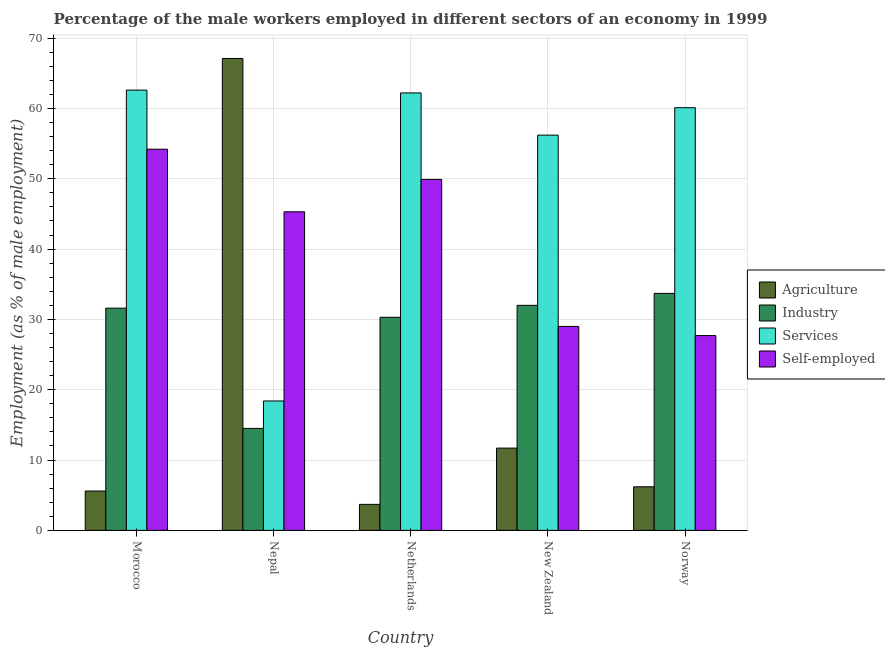How many different coloured bars are there?
Your answer should be very brief. 4. How many bars are there on the 1st tick from the left?
Your response must be concise. 4. In how many cases, is the number of bars for a given country not equal to the number of legend labels?
Offer a very short reply. 0. What is the percentage of male workers in services in Nepal?
Provide a short and direct response. 18.4. Across all countries, what is the maximum percentage of self employed male workers?
Keep it short and to the point. 54.2. Across all countries, what is the minimum percentage of male workers in agriculture?
Keep it short and to the point. 3.7. In which country was the percentage of male workers in industry maximum?
Provide a succinct answer. Norway. What is the total percentage of male workers in industry in the graph?
Make the answer very short. 142.1. What is the difference between the percentage of male workers in industry in Nepal and that in Norway?
Keep it short and to the point. -19.2. What is the difference between the percentage of male workers in industry in New Zealand and the percentage of male workers in agriculture in Netherlands?
Offer a very short reply. 28.3. What is the average percentage of male workers in services per country?
Offer a very short reply. 51.9. What is the difference between the percentage of self employed male workers and percentage of male workers in services in New Zealand?
Your answer should be very brief. -27.2. What is the ratio of the percentage of male workers in agriculture in Morocco to that in New Zealand?
Keep it short and to the point. 0.48. Is the percentage of male workers in services in Nepal less than that in Norway?
Provide a succinct answer. Yes. Is the difference between the percentage of male workers in agriculture in Netherlands and Norway greater than the difference between the percentage of male workers in services in Netherlands and Norway?
Your response must be concise. No. What is the difference between the highest and the second highest percentage of male workers in services?
Ensure brevity in your answer.  0.4. What is the difference between the highest and the lowest percentage of male workers in industry?
Your response must be concise. 19.2. Is it the case that in every country, the sum of the percentage of male workers in agriculture and percentage of self employed male workers is greater than the sum of percentage of male workers in industry and percentage of male workers in services?
Give a very brief answer. No. What does the 4th bar from the left in New Zealand represents?
Ensure brevity in your answer.  Self-employed. What does the 4th bar from the right in Netherlands represents?
Keep it short and to the point. Agriculture. Is it the case that in every country, the sum of the percentage of male workers in agriculture and percentage of male workers in industry is greater than the percentage of male workers in services?
Provide a succinct answer. No. Are the values on the major ticks of Y-axis written in scientific E-notation?
Keep it short and to the point. No. Does the graph contain any zero values?
Ensure brevity in your answer.  No. Does the graph contain grids?
Give a very brief answer. Yes. Where does the legend appear in the graph?
Offer a very short reply. Center right. How many legend labels are there?
Offer a terse response. 4. What is the title of the graph?
Keep it short and to the point. Percentage of the male workers employed in different sectors of an economy in 1999. What is the label or title of the Y-axis?
Give a very brief answer. Employment (as % of male employment). What is the Employment (as % of male employment) of Agriculture in Morocco?
Ensure brevity in your answer.  5.6. What is the Employment (as % of male employment) in Industry in Morocco?
Your answer should be very brief. 31.6. What is the Employment (as % of male employment) in Services in Morocco?
Make the answer very short. 62.6. What is the Employment (as % of male employment) in Self-employed in Morocco?
Provide a succinct answer. 54.2. What is the Employment (as % of male employment) in Agriculture in Nepal?
Offer a very short reply. 67.1. What is the Employment (as % of male employment) in Services in Nepal?
Keep it short and to the point. 18.4. What is the Employment (as % of male employment) of Self-employed in Nepal?
Offer a very short reply. 45.3. What is the Employment (as % of male employment) in Agriculture in Netherlands?
Keep it short and to the point. 3.7. What is the Employment (as % of male employment) of Industry in Netherlands?
Keep it short and to the point. 30.3. What is the Employment (as % of male employment) of Services in Netherlands?
Keep it short and to the point. 62.2. What is the Employment (as % of male employment) of Self-employed in Netherlands?
Offer a very short reply. 49.9. What is the Employment (as % of male employment) of Agriculture in New Zealand?
Offer a terse response. 11.7. What is the Employment (as % of male employment) of Services in New Zealand?
Your answer should be very brief. 56.2. What is the Employment (as % of male employment) of Self-employed in New Zealand?
Ensure brevity in your answer.  29. What is the Employment (as % of male employment) in Agriculture in Norway?
Keep it short and to the point. 6.2. What is the Employment (as % of male employment) of Industry in Norway?
Offer a terse response. 33.7. What is the Employment (as % of male employment) of Services in Norway?
Your response must be concise. 60.1. What is the Employment (as % of male employment) of Self-employed in Norway?
Your answer should be very brief. 27.7. Across all countries, what is the maximum Employment (as % of male employment) of Agriculture?
Provide a succinct answer. 67.1. Across all countries, what is the maximum Employment (as % of male employment) in Industry?
Provide a succinct answer. 33.7. Across all countries, what is the maximum Employment (as % of male employment) in Services?
Make the answer very short. 62.6. Across all countries, what is the maximum Employment (as % of male employment) in Self-employed?
Offer a terse response. 54.2. Across all countries, what is the minimum Employment (as % of male employment) of Agriculture?
Your response must be concise. 3.7. Across all countries, what is the minimum Employment (as % of male employment) in Industry?
Provide a short and direct response. 14.5. Across all countries, what is the minimum Employment (as % of male employment) of Services?
Give a very brief answer. 18.4. Across all countries, what is the minimum Employment (as % of male employment) of Self-employed?
Ensure brevity in your answer.  27.7. What is the total Employment (as % of male employment) in Agriculture in the graph?
Give a very brief answer. 94.3. What is the total Employment (as % of male employment) in Industry in the graph?
Your response must be concise. 142.1. What is the total Employment (as % of male employment) in Services in the graph?
Provide a short and direct response. 259.5. What is the total Employment (as % of male employment) in Self-employed in the graph?
Your answer should be compact. 206.1. What is the difference between the Employment (as % of male employment) of Agriculture in Morocco and that in Nepal?
Keep it short and to the point. -61.5. What is the difference between the Employment (as % of male employment) in Industry in Morocco and that in Nepal?
Provide a short and direct response. 17.1. What is the difference between the Employment (as % of male employment) in Services in Morocco and that in Nepal?
Your response must be concise. 44.2. What is the difference between the Employment (as % of male employment) in Agriculture in Morocco and that in Netherlands?
Offer a terse response. 1.9. What is the difference between the Employment (as % of male employment) in Industry in Morocco and that in Netherlands?
Your answer should be very brief. 1.3. What is the difference between the Employment (as % of male employment) of Services in Morocco and that in Netherlands?
Keep it short and to the point. 0.4. What is the difference between the Employment (as % of male employment) of Agriculture in Morocco and that in New Zealand?
Your answer should be compact. -6.1. What is the difference between the Employment (as % of male employment) of Industry in Morocco and that in New Zealand?
Your answer should be very brief. -0.4. What is the difference between the Employment (as % of male employment) of Services in Morocco and that in New Zealand?
Provide a succinct answer. 6.4. What is the difference between the Employment (as % of male employment) in Self-employed in Morocco and that in New Zealand?
Keep it short and to the point. 25.2. What is the difference between the Employment (as % of male employment) of Agriculture in Morocco and that in Norway?
Ensure brevity in your answer.  -0.6. What is the difference between the Employment (as % of male employment) of Industry in Morocco and that in Norway?
Your answer should be very brief. -2.1. What is the difference between the Employment (as % of male employment) of Services in Morocco and that in Norway?
Provide a succinct answer. 2.5. What is the difference between the Employment (as % of male employment) in Agriculture in Nepal and that in Netherlands?
Provide a succinct answer. 63.4. What is the difference between the Employment (as % of male employment) in Industry in Nepal and that in Netherlands?
Provide a short and direct response. -15.8. What is the difference between the Employment (as % of male employment) in Services in Nepal and that in Netherlands?
Your answer should be very brief. -43.8. What is the difference between the Employment (as % of male employment) of Self-employed in Nepal and that in Netherlands?
Your answer should be very brief. -4.6. What is the difference between the Employment (as % of male employment) of Agriculture in Nepal and that in New Zealand?
Offer a terse response. 55.4. What is the difference between the Employment (as % of male employment) in Industry in Nepal and that in New Zealand?
Give a very brief answer. -17.5. What is the difference between the Employment (as % of male employment) in Services in Nepal and that in New Zealand?
Your response must be concise. -37.8. What is the difference between the Employment (as % of male employment) of Agriculture in Nepal and that in Norway?
Give a very brief answer. 60.9. What is the difference between the Employment (as % of male employment) in Industry in Nepal and that in Norway?
Your answer should be very brief. -19.2. What is the difference between the Employment (as % of male employment) in Services in Nepal and that in Norway?
Offer a terse response. -41.7. What is the difference between the Employment (as % of male employment) in Self-employed in Nepal and that in Norway?
Your answer should be very brief. 17.6. What is the difference between the Employment (as % of male employment) of Agriculture in Netherlands and that in New Zealand?
Provide a short and direct response. -8. What is the difference between the Employment (as % of male employment) in Industry in Netherlands and that in New Zealand?
Make the answer very short. -1.7. What is the difference between the Employment (as % of male employment) in Self-employed in Netherlands and that in New Zealand?
Your answer should be compact. 20.9. What is the difference between the Employment (as % of male employment) of Services in Netherlands and that in Norway?
Offer a terse response. 2.1. What is the difference between the Employment (as % of male employment) in Self-employed in Netherlands and that in Norway?
Provide a succinct answer. 22.2. What is the difference between the Employment (as % of male employment) of Industry in New Zealand and that in Norway?
Offer a very short reply. -1.7. What is the difference between the Employment (as % of male employment) of Services in New Zealand and that in Norway?
Your answer should be compact. -3.9. What is the difference between the Employment (as % of male employment) of Self-employed in New Zealand and that in Norway?
Make the answer very short. 1.3. What is the difference between the Employment (as % of male employment) in Agriculture in Morocco and the Employment (as % of male employment) in Industry in Nepal?
Your response must be concise. -8.9. What is the difference between the Employment (as % of male employment) in Agriculture in Morocco and the Employment (as % of male employment) in Self-employed in Nepal?
Your response must be concise. -39.7. What is the difference between the Employment (as % of male employment) in Industry in Morocco and the Employment (as % of male employment) in Self-employed in Nepal?
Provide a succinct answer. -13.7. What is the difference between the Employment (as % of male employment) of Services in Morocco and the Employment (as % of male employment) of Self-employed in Nepal?
Offer a very short reply. 17.3. What is the difference between the Employment (as % of male employment) in Agriculture in Morocco and the Employment (as % of male employment) in Industry in Netherlands?
Your answer should be very brief. -24.7. What is the difference between the Employment (as % of male employment) in Agriculture in Morocco and the Employment (as % of male employment) in Services in Netherlands?
Offer a very short reply. -56.6. What is the difference between the Employment (as % of male employment) of Agriculture in Morocco and the Employment (as % of male employment) of Self-employed in Netherlands?
Provide a succinct answer. -44.3. What is the difference between the Employment (as % of male employment) of Industry in Morocco and the Employment (as % of male employment) of Services in Netherlands?
Give a very brief answer. -30.6. What is the difference between the Employment (as % of male employment) of Industry in Morocco and the Employment (as % of male employment) of Self-employed in Netherlands?
Your answer should be very brief. -18.3. What is the difference between the Employment (as % of male employment) of Services in Morocco and the Employment (as % of male employment) of Self-employed in Netherlands?
Provide a short and direct response. 12.7. What is the difference between the Employment (as % of male employment) of Agriculture in Morocco and the Employment (as % of male employment) of Industry in New Zealand?
Offer a very short reply. -26.4. What is the difference between the Employment (as % of male employment) in Agriculture in Morocco and the Employment (as % of male employment) in Services in New Zealand?
Offer a terse response. -50.6. What is the difference between the Employment (as % of male employment) of Agriculture in Morocco and the Employment (as % of male employment) of Self-employed in New Zealand?
Your answer should be compact. -23.4. What is the difference between the Employment (as % of male employment) in Industry in Morocco and the Employment (as % of male employment) in Services in New Zealand?
Offer a terse response. -24.6. What is the difference between the Employment (as % of male employment) of Services in Morocco and the Employment (as % of male employment) of Self-employed in New Zealand?
Your answer should be compact. 33.6. What is the difference between the Employment (as % of male employment) of Agriculture in Morocco and the Employment (as % of male employment) of Industry in Norway?
Provide a short and direct response. -28.1. What is the difference between the Employment (as % of male employment) of Agriculture in Morocco and the Employment (as % of male employment) of Services in Norway?
Keep it short and to the point. -54.5. What is the difference between the Employment (as % of male employment) of Agriculture in Morocco and the Employment (as % of male employment) of Self-employed in Norway?
Your answer should be compact. -22.1. What is the difference between the Employment (as % of male employment) of Industry in Morocco and the Employment (as % of male employment) of Services in Norway?
Your answer should be very brief. -28.5. What is the difference between the Employment (as % of male employment) in Industry in Morocco and the Employment (as % of male employment) in Self-employed in Norway?
Provide a short and direct response. 3.9. What is the difference between the Employment (as % of male employment) of Services in Morocco and the Employment (as % of male employment) of Self-employed in Norway?
Provide a short and direct response. 34.9. What is the difference between the Employment (as % of male employment) of Agriculture in Nepal and the Employment (as % of male employment) of Industry in Netherlands?
Give a very brief answer. 36.8. What is the difference between the Employment (as % of male employment) in Agriculture in Nepal and the Employment (as % of male employment) in Self-employed in Netherlands?
Your answer should be compact. 17.2. What is the difference between the Employment (as % of male employment) in Industry in Nepal and the Employment (as % of male employment) in Services in Netherlands?
Provide a short and direct response. -47.7. What is the difference between the Employment (as % of male employment) of Industry in Nepal and the Employment (as % of male employment) of Self-employed in Netherlands?
Provide a succinct answer. -35.4. What is the difference between the Employment (as % of male employment) in Services in Nepal and the Employment (as % of male employment) in Self-employed in Netherlands?
Offer a terse response. -31.5. What is the difference between the Employment (as % of male employment) in Agriculture in Nepal and the Employment (as % of male employment) in Industry in New Zealand?
Offer a terse response. 35.1. What is the difference between the Employment (as % of male employment) of Agriculture in Nepal and the Employment (as % of male employment) of Self-employed in New Zealand?
Offer a very short reply. 38.1. What is the difference between the Employment (as % of male employment) in Industry in Nepal and the Employment (as % of male employment) in Services in New Zealand?
Provide a short and direct response. -41.7. What is the difference between the Employment (as % of male employment) in Industry in Nepal and the Employment (as % of male employment) in Self-employed in New Zealand?
Give a very brief answer. -14.5. What is the difference between the Employment (as % of male employment) of Services in Nepal and the Employment (as % of male employment) of Self-employed in New Zealand?
Give a very brief answer. -10.6. What is the difference between the Employment (as % of male employment) in Agriculture in Nepal and the Employment (as % of male employment) in Industry in Norway?
Keep it short and to the point. 33.4. What is the difference between the Employment (as % of male employment) in Agriculture in Nepal and the Employment (as % of male employment) in Services in Norway?
Your answer should be compact. 7. What is the difference between the Employment (as % of male employment) of Agriculture in Nepal and the Employment (as % of male employment) of Self-employed in Norway?
Your answer should be very brief. 39.4. What is the difference between the Employment (as % of male employment) of Industry in Nepal and the Employment (as % of male employment) of Services in Norway?
Provide a succinct answer. -45.6. What is the difference between the Employment (as % of male employment) in Industry in Nepal and the Employment (as % of male employment) in Self-employed in Norway?
Make the answer very short. -13.2. What is the difference between the Employment (as % of male employment) of Services in Nepal and the Employment (as % of male employment) of Self-employed in Norway?
Offer a terse response. -9.3. What is the difference between the Employment (as % of male employment) of Agriculture in Netherlands and the Employment (as % of male employment) of Industry in New Zealand?
Give a very brief answer. -28.3. What is the difference between the Employment (as % of male employment) of Agriculture in Netherlands and the Employment (as % of male employment) of Services in New Zealand?
Make the answer very short. -52.5. What is the difference between the Employment (as % of male employment) of Agriculture in Netherlands and the Employment (as % of male employment) of Self-employed in New Zealand?
Your answer should be very brief. -25.3. What is the difference between the Employment (as % of male employment) of Industry in Netherlands and the Employment (as % of male employment) of Services in New Zealand?
Offer a terse response. -25.9. What is the difference between the Employment (as % of male employment) in Services in Netherlands and the Employment (as % of male employment) in Self-employed in New Zealand?
Make the answer very short. 33.2. What is the difference between the Employment (as % of male employment) in Agriculture in Netherlands and the Employment (as % of male employment) in Services in Norway?
Your answer should be compact. -56.4. What is the difference between the Employment (as % of male employment) of Industry in Netherlands and the Employment (as % of male employment) of Services in Norway?
Ensure brevity in your answer.  -29.8. What is the difference between the Employment (as % of male employment) of Services in Netherlands and the Employment (as % of male employment) of Self-employed in Norway?
Your response must be concise. 34.5. What is the difference between the Employment (as % of male employment) in Agriculture in New Zealand and the Employment (as % of male employment) in Industry in Norway?
Offer a terse response. -22. What is the difference between the Employment (as % of male employment) in Agriculture in New Zealand and the Employment (as % of male employment) in Services in Norway?
Offer a terse response. -48.4. What is the difference between the Employment (as % of male employment) of Industry in New Zealand and the Employment (as % of male employment) of Services in Norway?
Provide a short and direct response. -28.1. What is the difference between the Employment (as % of male employment) in Industry in New Zealand and the Employment (as % of male employment) in Self-employed in Norway?
Your answer should be compact. 4.3. What is the average Employment (as % of male employment) of Agriculture per country?
Your response must be concise. 18.86. What is the average Employment (as % of male employment) of Industry per country?
Make the answer very short. 28.42. What is the average Employment (as % of male employment) of Services per country?
Provide a succinct answer. 51.9. What is the average Employment (as % of male employment) of Self-employed per country?
Offer a terse response. 41.22. What is the difference between the Employment (as % of male employment) of Agriculture and Employment (as % of male employment) of Services in Morocco?
Offer a terse response. -57. What is the difference between the Employment (as % of male employment) in Agriculture and Employment (as % of male employment) in Self-employed in Morocco?
Provide a succinct answer. -48.6. What is the difference between the Employment (as % of male employment) in Industry and Employment (as % of male employment) in Services in Morocco?
Make the answer very short. -31. What is the difference between the Employment (as % of male employment) in Industry and Employment (as % of male employment) in Self-employed in Morocco?
Offer a very short reply. -22.6. What is the difference between the Employment (as % of male employment) in Services and Employment (as % of male employment) in Self-employed in Morocco?
Ensure brevity in your answer.  8.4. What is the difference between the Employment (as % of male employment) of Agriculture and Employment (as % of male employment) of Industry in Nepal?
Your answer should be very brief. 52.6. What is the difference between the Employment (as % of male employment) in Agriculture and Employment (as % of male employment) in Services in Nepal?
Provide a succinct answer. 48.7. What is the difference between the Employment (as % of male employment) in Agriculture and Employment (as % of male employment) in Self-employed in Nepal?
Offer a terse response. 21.8. What is the difference between the Employment (as % of male employment) of Industry and Employment (as % of male employment) of Services in Nepal?
Your answer should be compact. -3.9. What is the difference between the Employment (as % of male employment) in Industry and Employment (as % of male employment) in Self-employed in Nepal?
Your response must be concise. -30.8. What is the difference between the Employment (as % of male employment) in Services and Employment (as % of male employment) in Self-employed in Nepal?
Provide a short and direct response. -26.9. What is the difference between the Employment (as % of male employment) in Agriculture and Employment (as % of male employment) in Industry in Netherlands?
Ensure brevity in your answer.  -26.6. What is the difference between the Employment (as % of male employment) of Agriculture and Employment (as % of male employment) of Services in Netherlands?
Offer a very short reply. -58.5. What is the difference between the Employment (as % of male employment) of Agriculture and Employment (as % of male employment) of Self-employed in Netherlands?
Keep it short and to the point. -46.2. What is the difference between the Employment (as % of male employment) in Industry and Employment (as % of male employment) in Services in Netherlands?
Provide a succinct answer. -31.9. What is the difference between the Employment (as % of male employment) of Industry and Employment (as % of male employment) of Self-employed in Netherlands?
Your response must be concise. -19.6. What is the difference between the Employment (as % of male employment) in Agriculture and Employment (as % of male employment) in Industry in New Zealand?
Offer a terse response. -20.3. What is the difference between the Employment (as % of male employment) of Agriculture and Employment (as % of male employment) of Services in New Zealand?
Offer a very short reply. -44.5. What is the difference between the Employment (as % of male employment) in Agriculture and Employment (as % of male employment) in Self-employed in New Zealand?
Ensure brevity in your answer.  -17.3. What is the difference between the Employment (as % of male employment) in Industry and Employment (as % of male employment) in Services in New Zealand?
Your response must be concise. -24.2. What is the difference between the Employment (as % of male employment) of Services and Employment (as % of male employment) of Self-employed in New Zealand?
Offer a very short reply. 27.2. What is the difference between the Employment (as % of male employment) of Agriculture and Employment (as % of male employment) of Industry in Norway?
Ensure brevity in your answer.  -27.5. What is the difference between the Employment (as % of male employment) of Agriculture and Employment (as % of male employment) of Services in Norway?
Offer a terse response. -53.9. What is the difference between the Employment (as % of male employment) in Agriculture and Employment (as % of male employment) in Self-employed in Norway?
Provide a short and direct response. -21.5. What is the difference between the Employment (as % of male employment) in Industry and Employment (as % of male employment) in Services in Norway?
Make the answer very short. -26.4. What is the difference between the Employment (as % of male employment) in Services and Employment (as % of male employment) in Self-employed in Norway?
Give a very brief answer. 32.4. What is the ratio of the Employment (as % of male employment) of Agriculture in Morocco to that in Nepal?
Provide a short and direct response. 0.08. What is the ratio of the Employment (as % of male employment) of Industry in Morocco to that in Nepal?
Offer a terse response. 2.18. What is the ratio of the Employment (as % of male employment) in Services in Morocco to that in Nepal?
Offer a very short reply. 3.4. What is the ratio of the Employment (as % of male employment) in Self-employed in Morocco to that in Nepal?
Your answer should be very brief. 1.2. What is the ratio of the Employment (as % of male employment) of Agriculture in Morocco to that in Netherlands?
Keep it short and to the point. 1.51. What is the ratio of the Employment (as % of male employment) of Industry in Morocco to that in Netherlands?
Offer a very short reply. 1.04. What is the ratio of the Employment (as % of male employment) in Services in Morocco to that in Netherlands?
Your response must be concise. 1.01. What is the ratio of the Employment (as % of male employment) of Self-employed in Morocco to that in Netherlands?
Ensure brevity in your answer.  1.09. What is the ratio of the Employment (as % of male employment) in Agriculture in Morocco to that in New Zealand?
Your answer should be very brief. 0.48. What is the ratio of the Employment (as % of male employment) of Industry in Morocco to that in New Zealand?
Make the answer very short. 0.99. What is the ratio of the Employment (as % of male employment) of Services in Morocco to that in New Zealand?
Your response must be concise. 1.11. What is the ratio of the Employment (as % of male employment) in Self-employed in Morocco to that in New Zealand?
Your answer should be very brief. 1.87. What is the ratio of the Employment (as % of male employment) in Agriculture in Morocco to that in Norway?
Your response must be concise. 0.9. What is the ratio of the Employment (as % of male employment) in Industry in Morocco to that in Norway?
Give a very brief answer. 0.94. What is the ratio of the Employment (as % of male employment) of Services in Morocco to that in Norway?
Offer a terse response. 1.04. What is the ratio of the Employment (as % of male employment) in Self-employed in Morocco to that in Norway?
Your answer should be compact. 1.96. What is the ratio of the Employment (as % of male employment) of Agriculture in Nepal to that in Netherlands?
Provide a short and direct response. 18.14. What is the ratio of the Employment (as % of male employment) of Industry in Nepal to that in Netherlands?
Your answer should be compact. 0.48. What is the ratio of the Employment (as % of male employment) in Services in Nepal to that in Netherlands?
Provide a succinct answer. 0.3. What is the ratio of the Employment (as % of male employment) of Self-employed in Nepal to that in Netherlands?
Provide a short and direct response. 0.91. What is the ratio of the Employment (as % of male employment) in Agriculture in Nepal to that in New Zealand?
Make the answer very short. 5.74. What is the ratio of the Employment (as % of male employment) in Industry in Nepal to that in New Zealand?
Make the answer very short. 0.45. What is the ratio of the Employment (as % of male employment) of Services in Nepal to that in New Zealand?
Offer a very short reply. 0.33. What is the ratio of the Employment (as % of male employment) in Self-employed in Nepal to that in New Zealand?
Offer a very short reply. 1.56. What is the ratio of the Employment (as % of male employment) in Agriculture in Nepal to that in Norway?
Provide a short and direct response. 10.82. What is the ratio of the Employment (as % of male employment) of Industry in Nepal to that in Norway?
Offer a very short reply. 0.43. What is the ratio of the Employment (as % of male employment) in Services in Nepal to that in Norway?
Give a very brief answer. 0.31. What is the ratio of the Employment (as % of male employment) in Self-employed in Nepal to that in Norway?
Your answer should be very brief. 1.64. What is the ratio of the Employment (as % of male employment) of Agriculture in Netherlands to that in New Zealand?
Provide a short and direct response. 0.32. What is the ratio of the Employment (as % of male employment) of Industry in Netherlands to that in New Zealand?
Your answer should be compact. 0.95. What is the ratio of the Employment (as % of male employment) in Services in Netherlands to that in New Zealand?
Provide a succinct answer. 1.11. What is the ratio of the Employment (as % of male employment) of Self-employed in Netherlands to that in New Zealand?
Provide a succinct answer. 1.72. What is the ratio of the Employment (as % of male employment) in Agriculture in Netherlands to that in Norway?
Your answer should be compact. 0.6. What is the ratio of the Employment (as % of male employment) in Industry in Netherlands to that in Norway?
Give a very brief answer. 0.9. What is the ratio of the Employment (as % of male employment) of Services in Netherlands to that in Norway?
Offer a very short reply. 1.03. What is the ratio of the Employment (as % of male employment) in Self-employed in Netherlands to that in Norway?
Your answer should be compact. 1.8. What is the ratio of the Employment (as % of male employment) of Agriculture in New Zealand to that in Norway?
Keep it short and to the point. 1.89. What is the ratio of the Employment (as % of male employment) in Industry in New Zealand to that in Norway?
Make the answer very short. 0.95. What is the ratio of the Employment (as % of male employment) in Services in New Zealand to that in Norway?
Make the answer very short. 0.94. What is the ratio of the Employment (as % of male employment) of Self-employed in New Zealand to that in Norway?
Provide a short and direct response. 1.05. What is the difference between the highest and the second highest Employment (as % of male employment) in Agriculture?
Your answer should be compact. 55.4. What is the difference between the highest and the lowest Employment (as % of male employment) of Agriculture?
Your answer should be compact. 63.4. What is the difference between the highest and the lowest Employment (as % of male employment) of Industry?
Offer a terse response. 19.2. What is the difference between the highest and the lowest Employment (as % of male employment) in Services?
Keep it short and to the point. 44.2. What is the difference between the highest and the lowest Employment (as % of male employment) of Self-employed?
Make the answer very short. 26.5. 